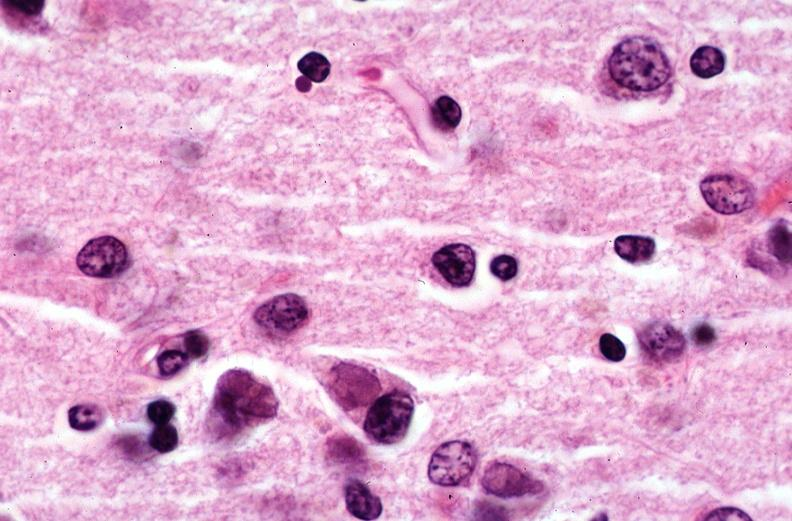what does this image show?
Answer the question using a single word or phrase. Brain 